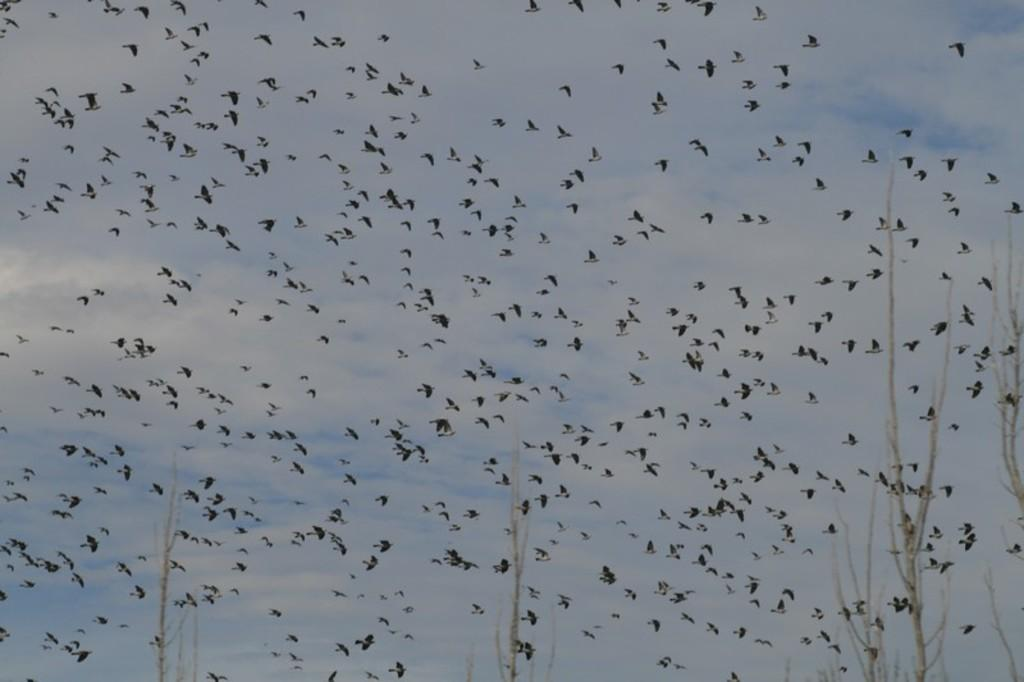What is happening in the sky in the image? There are birds flying in the sky. What type of vegetation can be seen in the image? There are trees visible in the image. What type of grain is being harvested in the image? There is no grain present in the image; it features birds flying in the sky and trees. What appliance is being used to prepare a meal in the image? There is no appliance or meal preparation visible in the image. 